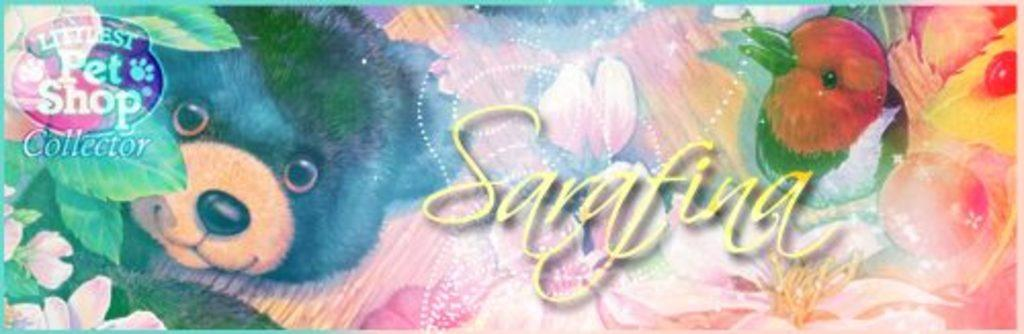What can be inferred about the nature of the image? The image appears to be an edited photo. Can you identify any text that might be present in the image? There may be text present in the image. What type of living creature might be present in the image? There may be a bird or an animal present in the image. What type of plant life might be present in the image? There may be flowers or leaves present in the image. Is there any branding or identification present in the image? There may be a logo present in the image. How many fish can be seen swimming in the image? There are no fish visible in the image. What type of currency can be seen in the image? There is no currency present in the image. 